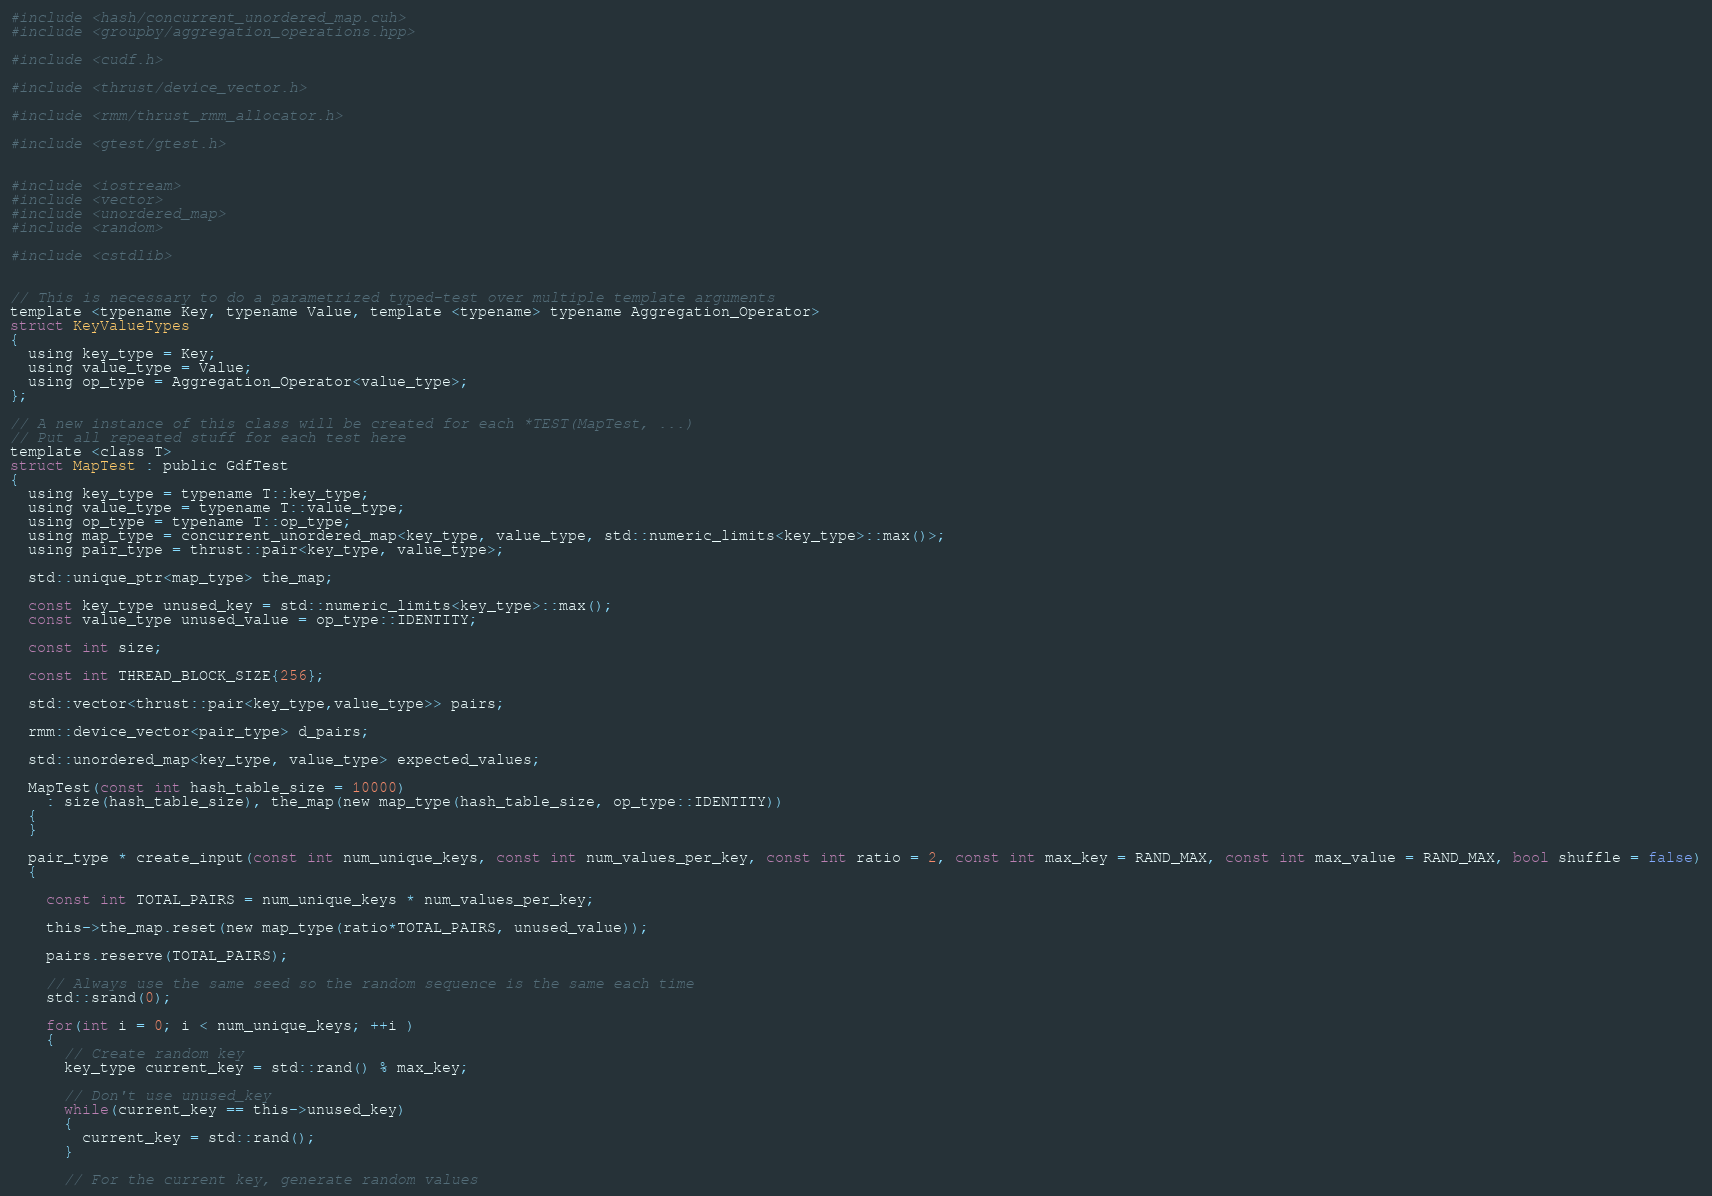Convert code to text. <code><loc_0><loc_0><loc_500><loc_500><_Cuda_>
#include <hash/concurrent_unordered_map.cuh>
#include <groupby/aggregation_operations.hpp>

#include <cudf.h>

#include <thrust/device_vector.h>

#include <rmm/thrust_rmm_allocator.h>

#include <gtest/gtest.h>


#include <iostream>
#include <vector>
#include <unordered_map>
#include <random>

#include <cstdlib>


// This is necessary to do a parametrized typed-test over multiple template arguments
template <typename Key, typename Value, template <typename> typename Aggregation_Operator>
struct KeyValueTypes
{
  using key_type = Key;
  using value_type = Value;
  using op_type = Aggregation_Operator<value_type>;
};

// A new instance of this class will be created for each *TEST(MapTest, ...)
// Put all repeated stuff for each test here
template <class T>
struct MapTest : public GdfTest
{
  using key_type = typename T::key_type;
  using value_type = typename T::value_type;
  using op_type = typename T::op_type;
  using map_type = concurrent_unordered_map<key_type, value_type, std::numeric_limits<key_type>::max()>;
  using pair_type = thrust::pair<key_type, value_type>;

  std::unique_ptr<map_type> the_map;

  const key_type unused_key = std::numeric_limits<key_type>::max();
  const value_type unused_value = op_type::IDENTITY;

  const int size;

  const int THREAD_BLOCK_SIZE{256};

  std::vector<thrust::pair<key_type,value_type>> pairs;

  rmm::device_vector<pair_type> d_pairs;

  std::unordered_map<key_type, value_type> expected_values;

  MapTest(const int hash_table_size = 10000)
    : size(hash_table_size), the_map(new map_type(hash_table_size, op_type::IDENTITY))
  {
  }

  pair_type * create_input(const int num_unique_keys, const int num_values_per_key, const int ratio = 2, const int max_key = RAND_MAX, const int max_value = RAND_MAX, bool shuffle = false)
  {

    const int TOTAL_PAIRS = num_unique_keys * num_values_per_key;

    this->the_map.reset(new map_type(ratio*TOTAL_PAIRS, unused_value));

    pairs.reserve(TOTAL_PAIRS);

    // Always use the same seed so the random sequence is the same each time
    std::srand(0);

    for(int i = 0; i < num_unique_keys; ++i )
    {
      // Create random key
      key_type current_key = std::rand() % max_key;

      // Don't use unused_key
      while(current_key == this->unused_key)
      {
        current_key = std::rand();
      }

      // For the current key, generate random values</code> 